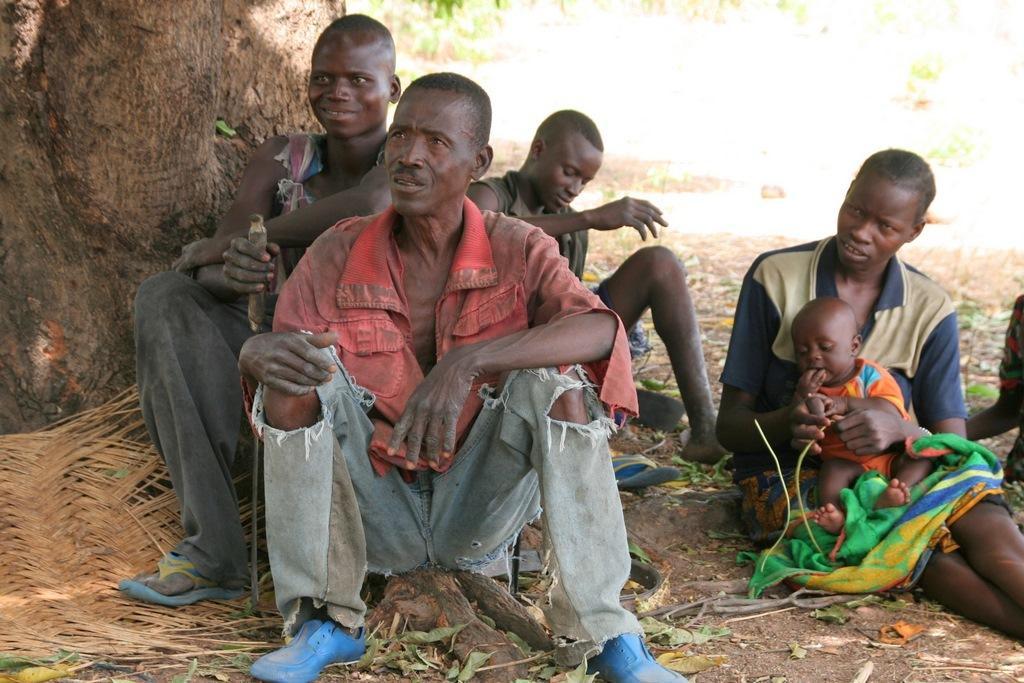Describe this image in one or two sentences. There are four people sitting. This person is holding a baby. I think this is a tree trunk. I can see the leaves lying on the ground. 